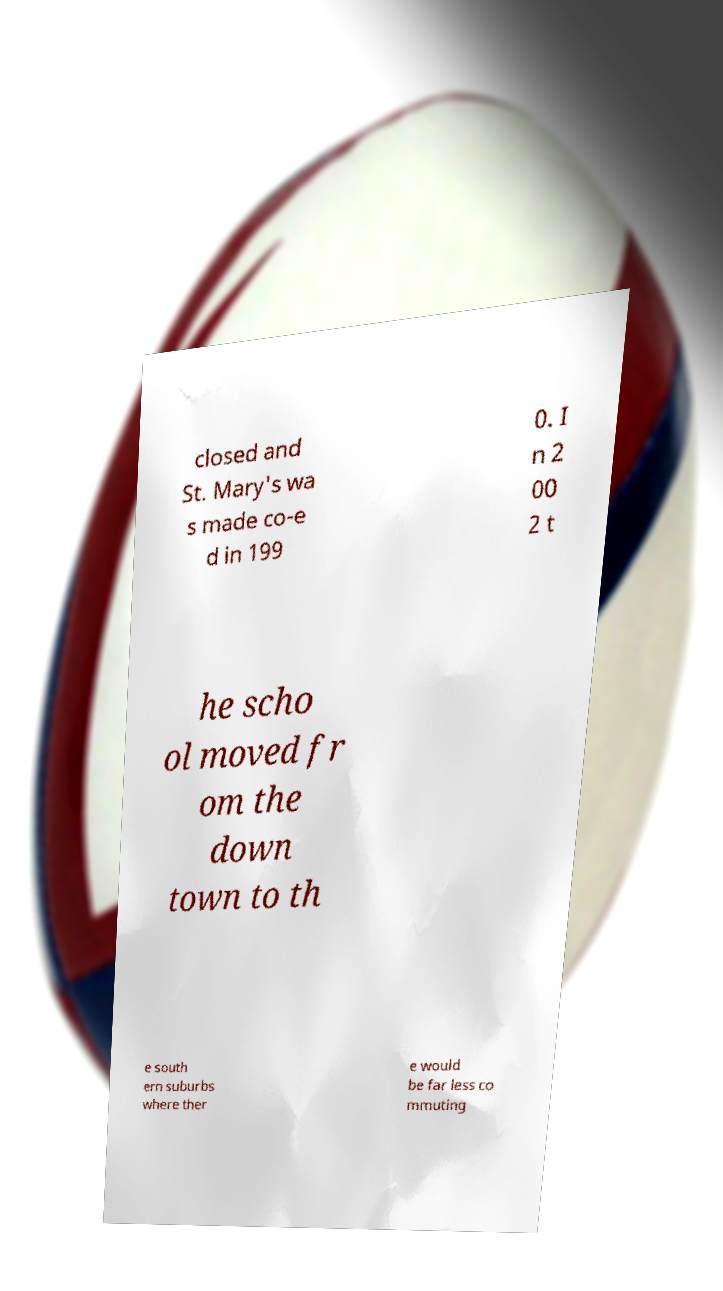For documentation purposes, I need the text within this image transcribed. Could you provide that? closed and St. Mary's wa s made co-e d in 199 0. I n 2 00 2 t he scho ol moved fr om the down town to th e south ern suburbs where ther e would be far less co mmuting 